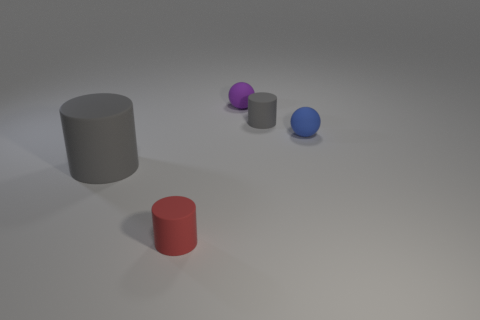Add 4 matte things. How many objects exist? 9 Subtract all balls. How many objects are left? 3 Subtract all small rubber objects. Subtract all big red rubber cylinders. How many objects are left? 1 Add 5 small things. How many small things are left? 9 Add 4 matte spheres. How many matte spheres exist? 6 Subtract 0 yellow spheres. How many objects are left? 5 